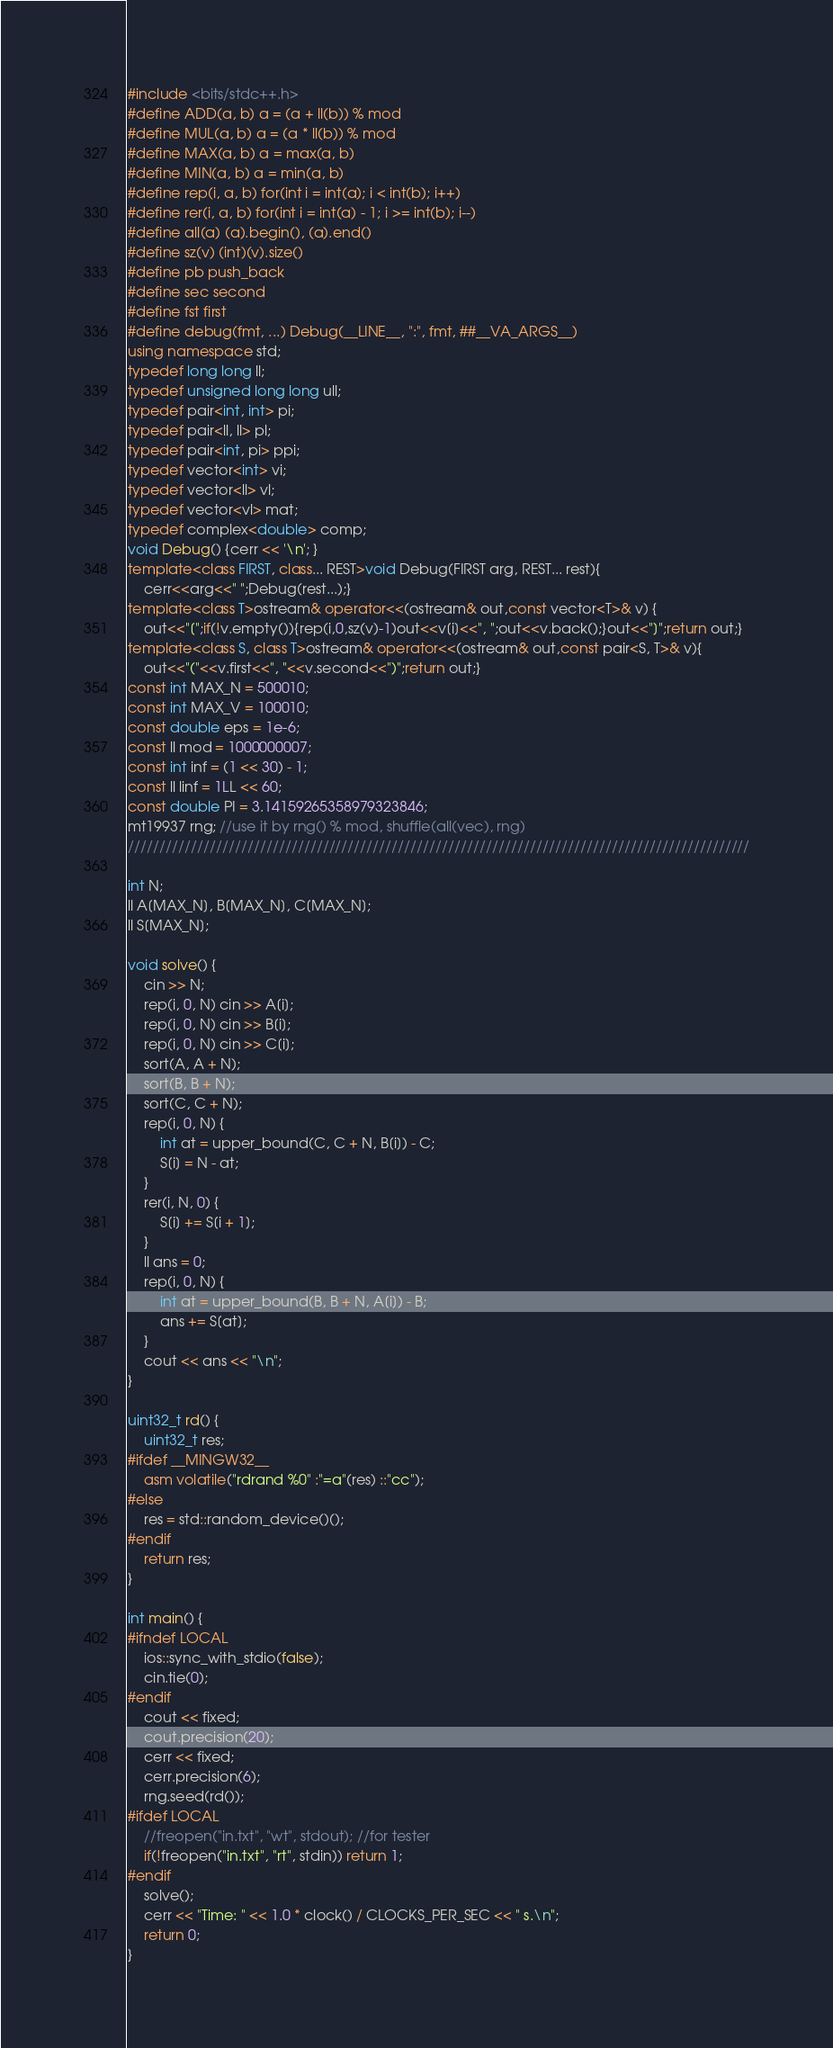<code> <loc_0><loc_0><loc_500><loc_500><_C++_>#include <bits/stdc++.h>
#define ADD(a, b) a = (a + ll(b)) % mod
#define MUL(a, b) a = (a * ll(b)) % mod
#define MAX(a, b) a = max(a, b)
#define MIN(a, b) a = min(a, b)
#define rep(i, a, b) for(int i = int(a); i < int(b); i++)
#define rer(i, a, b) for(int i = int(a) - 1; i >= int(b); i--)
#define all(a) (a).begin(), (a).end()
#define sz(v) (int)(v).size()
#define pb push_back
#define sec second
#define fst first
#define debug(fmt, ...) Debug(__LINE__, ":", fmt, ##__VA_ARGS__)
using namespace std;
typedef long long ll;
typedef unsigned long long ull;
typedef pair<int, int> pi;
typedef pair<ll, ll> pl;
typedef pair<int, pi> ppi;
typedef vector<int> vi;
typedef vector<ll> vl;
typedef vector<vl> mat;
typedef complex<double> comp;
void Debug() {cerr << '\n'; }
template<class FIRST, class... REST>void Debug(FIRST arg, REST... rest){
	cerr<<arg<<" ";Debug(rest...);}
template<class T>ostream& operator<<(ostream& out,const vector<T>& v) {
	out<<"[";if(!v.empty()){rep(i,0,sz(v)-1)out<<v[i]<<", ";out<<v.back();}out<<"]";return out;}
template<class S, class T>ostream& operator<<(ostream& out,const pair<S, T>& v){
	out<<"("<<v.first<<", "<<v.second<<")";return out;}
const int MAX_N = 500010;
const int MAX_V = 100010;
const double eps = 1e-6;
const ll mod = 1000000007;
const int inf = (1 << 30) - 1;
const ll linf = 1LL << 60;
const double PI = 3.14159265358979323846;
mt19937 rng; //use it by rng() % mod, shuffle(all(vec), rng)
///////////////////////////////////////////////////////////////////////////////////////////////////

int N;
ll A[MAX_N], B[MAX_N], C[MAX_N];
ll S[MAX_N];

void solve() {
	cin >> N;
	rep(i, 0, N) cin >> A[i];
	rep(i, 0, N) cin >> B[i];
	rep(i, 0, N) cin >> C[i];
	sort(A, A + N);
	sort(B, B + N);
	sort(C, C + N);
	rep(i, 0, N) {
		int at = upper_bound(C, C + N, B[i]) - C;
		S[i] = N - at;
	}
	rer(i, N, 0) {
		S[i] += S[i + 1];
	}
	ll ans = 0;
	rep(i, 0, N) {
		int at = upper_bound(B, B + N, A[i]) - B;
		ans += S[at];
	}
	cout << ans << "\n";
}

uint32_t rd() {
	uint32_t res;
#ifdef __MINGW32__
	asm volatile("rdrand %0" :"=a"(res) ::"cc");
#else
	res = std::random_device()();
#endif
	return res;
}

int main() {
#ifndef LOCAL
	ios::sync_with_stdio(false);
    cin.tie(0);
#endif
    cout << fixed;
	cout.precision(20);
    cerr << fixed;
	cerr.precision(6);
	rng.seed(rd());
#ifdef LOCAL
	//freopen("in.txt", "wt", stdout); //for tester
	if(!freopen("in.txt", "rt", stdin)) return 1;
#endif	
	solve();
    cerr << "Time: " << 1.0 * clock() / CLOCKS_PER_SEC << " s.\n";
	return 0;
}

</code> 